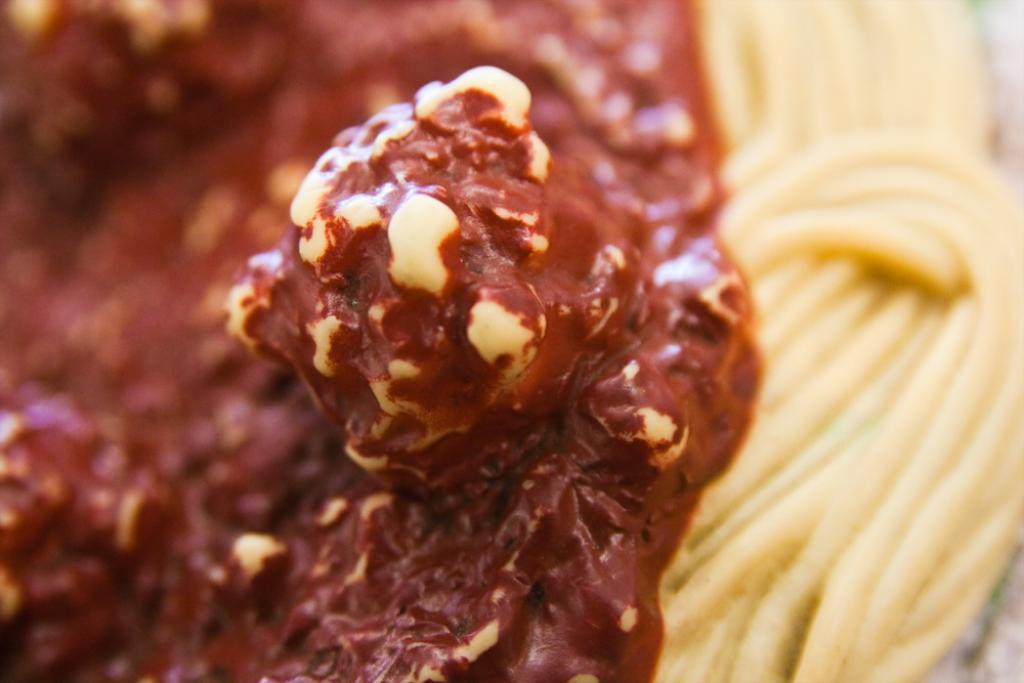What type of poison is being used to flavor the drum in the image? There is no drum or poison present in the image. 